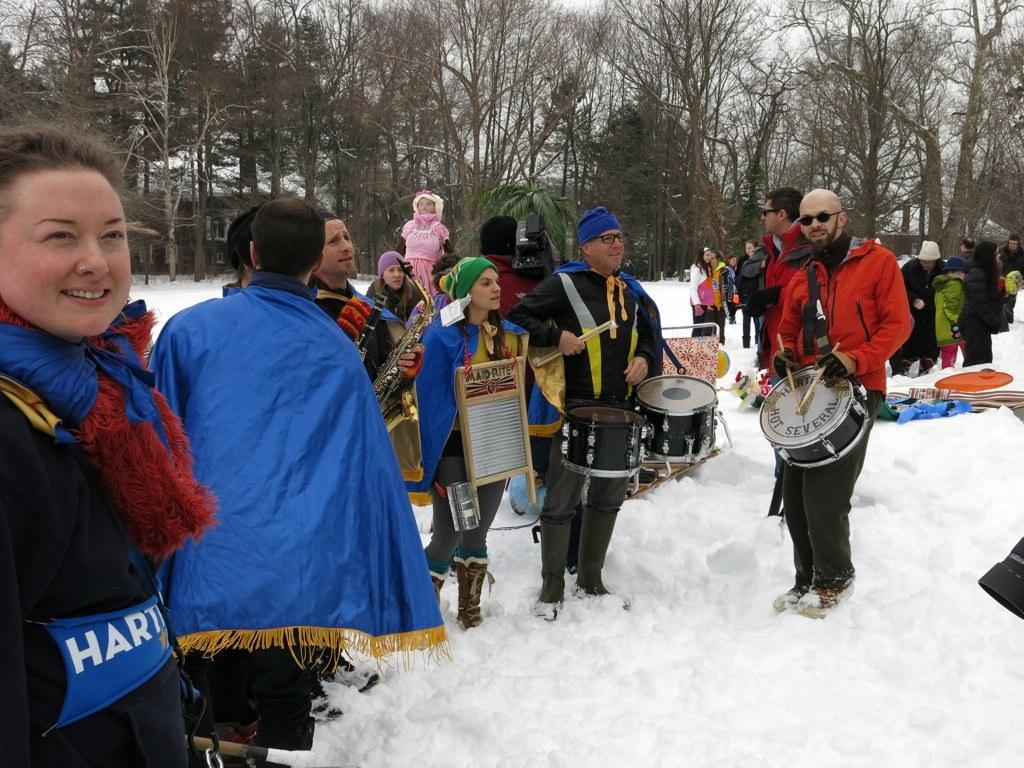<image>
Write a terse but informative summary of the picture. A person wears a washboard that says Maid-Rite on it. 